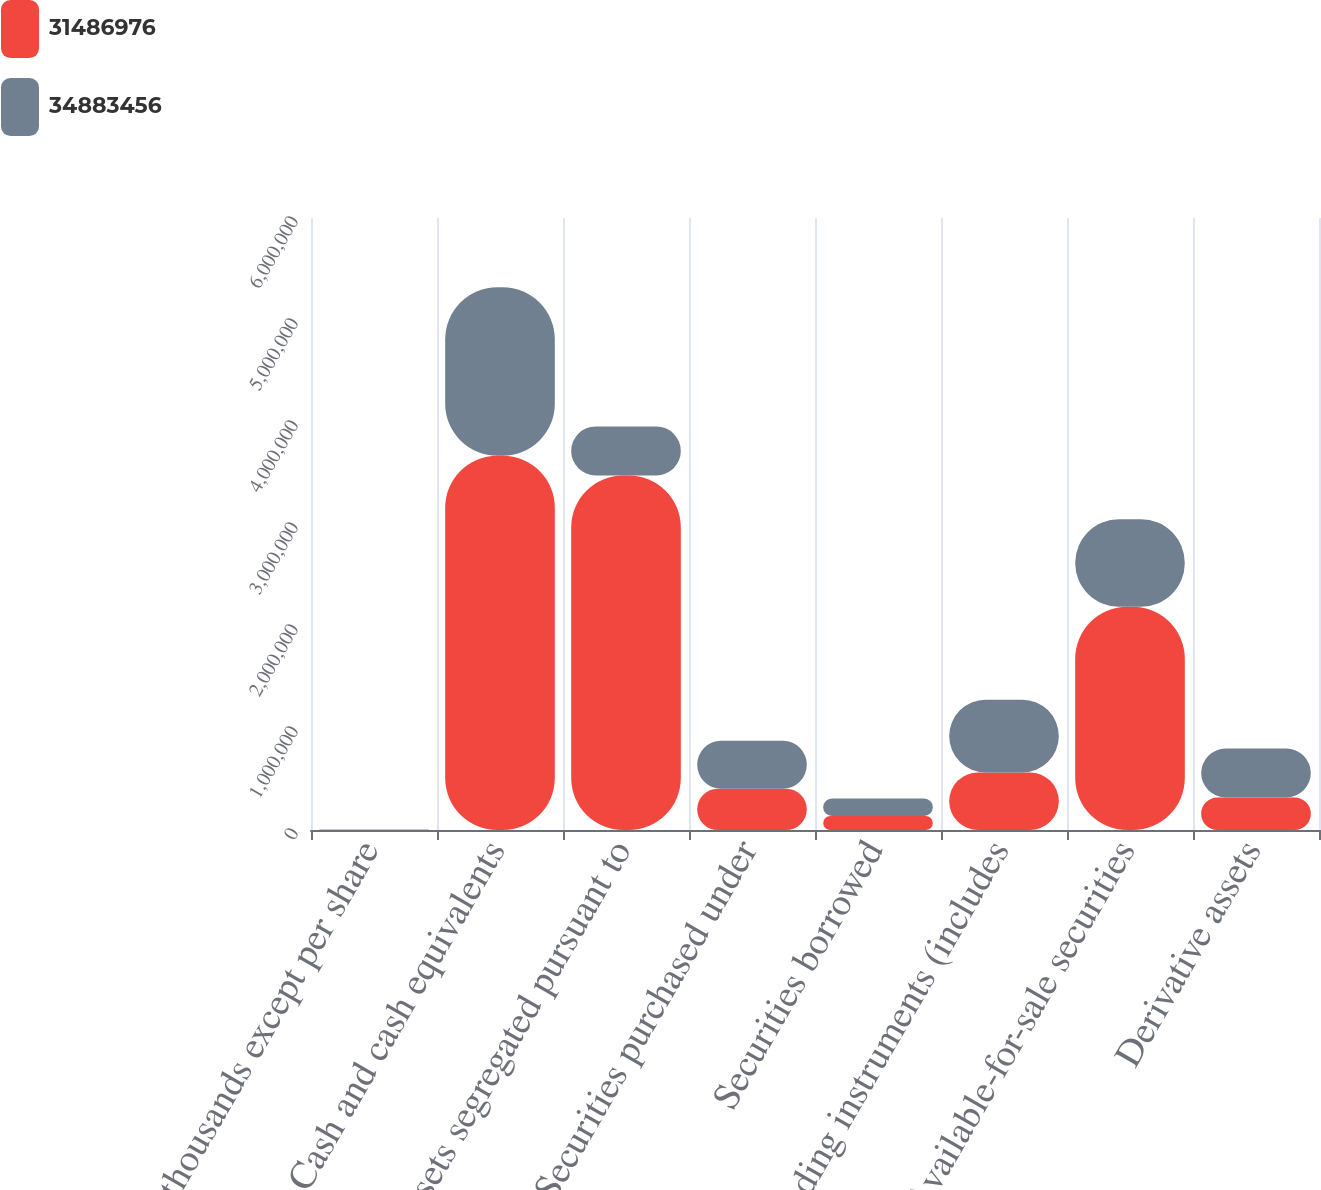Convert chart to OTSL. <chart><loc_0><loc_0><loc_500><loc_500><stacked_bar_chart><ecel><fcel>in thousands except per share<fcel>Cash and cash equivalents<fcel>Assets segregated pursuant to<fcel>Securities purchased under<fcel>Securities borrowed<fcel>Trading instruments (includes<fcel>Available-for-sale securities<fcel>Derivative assets<nl><fcel>3.1487e+07<fcel>2017<fcel>3.66967e+06<fcel>3.47608e+06<fcel>404462<fcel>138319<fcel>564263<fcel>2.18828e+06<fcel>318775<nl><fcel>3.48835e+07<fcel>2016<fcel>1.65045e+06<fcel>480106<fcel>470222<fcel>170860<fcel>713550<fcel>859398<fcel>480106<nl></chart> 